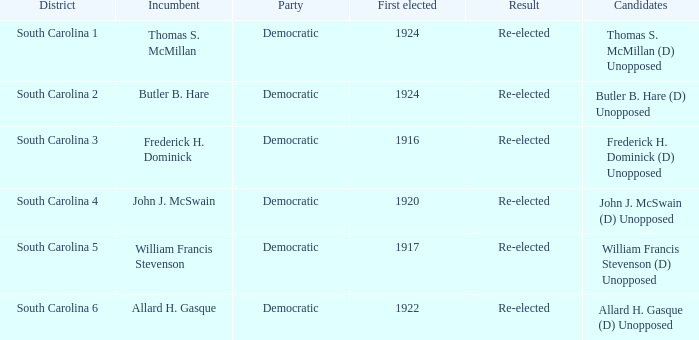What is the event for south carolina 3? Democratic. 